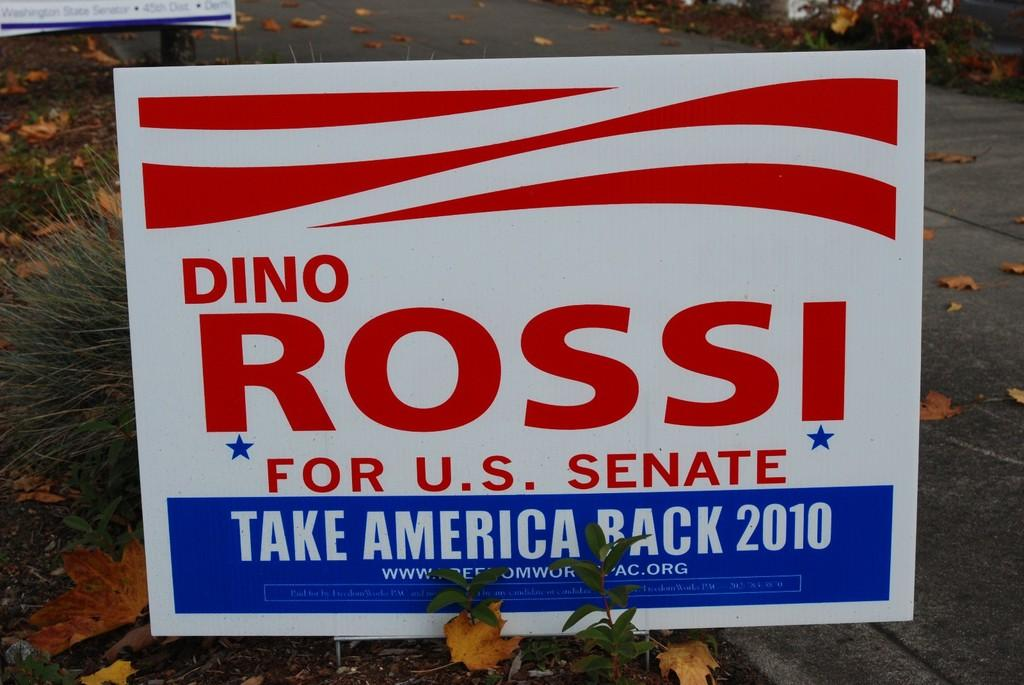<image>
Share a concise interpretation of the image provided. A political yard sign that says Rossi for senate. 